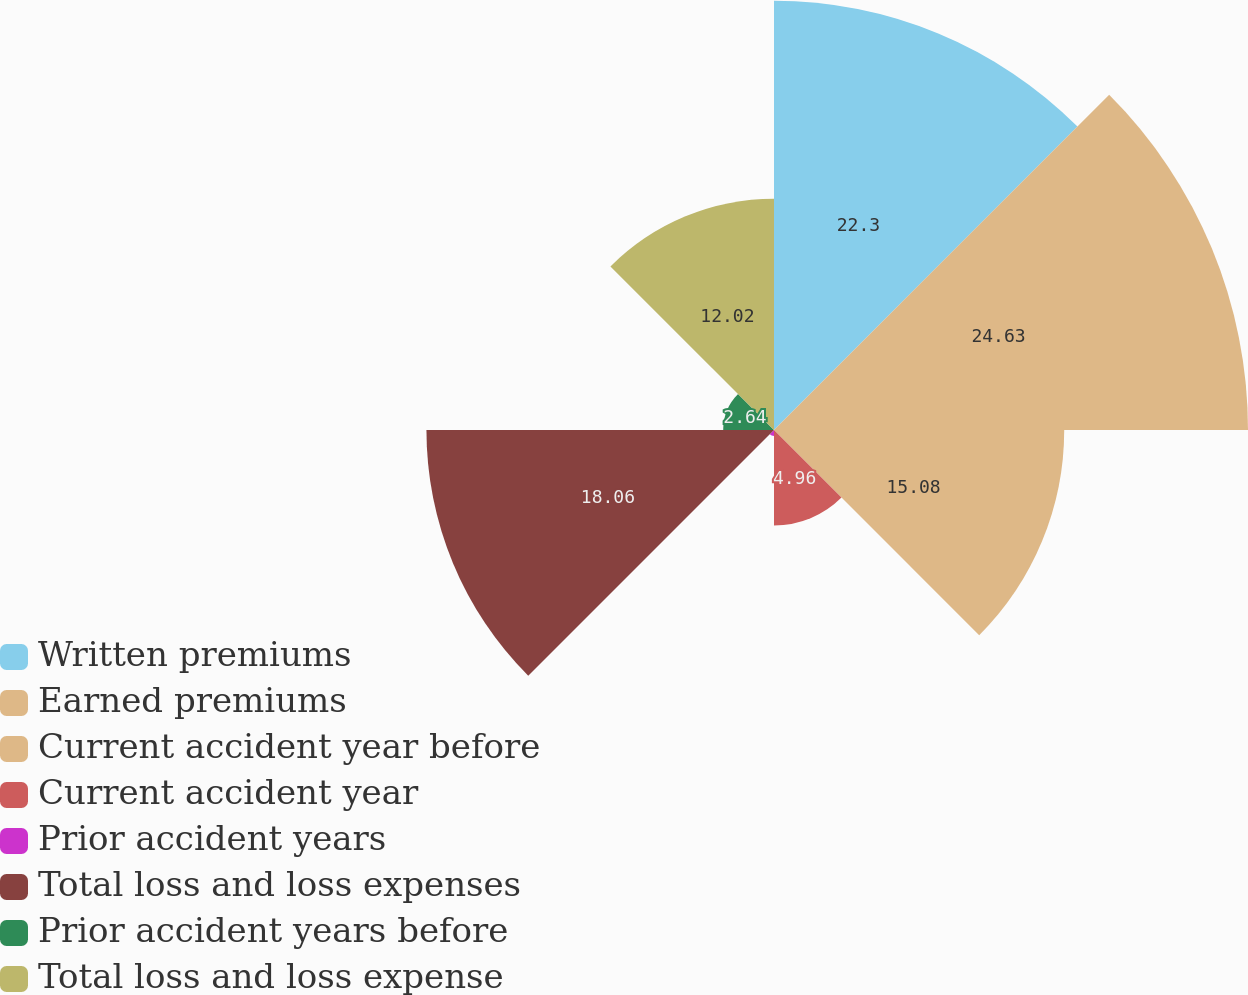Convert chart to OTSL. <chart><loc_0><loc_0><loc_500><loc_500><pie_chart><fcel>Written premiums<fcel>Earned premiums<fcel>Current accident year before<fcel>Current accident year<fcel>Prior accident years<fcel>Total loss and loss expenses<fcel>Prior accident years before<fcel>Total loss and loss expense<nl><fcel>22.3%<fcel>24.63%<fcel>15.08%<fcel>4.96%<fcel>0.31%<fcel>18.06%<fcel>2.64%<fcel>12.02%<nl></chart> 